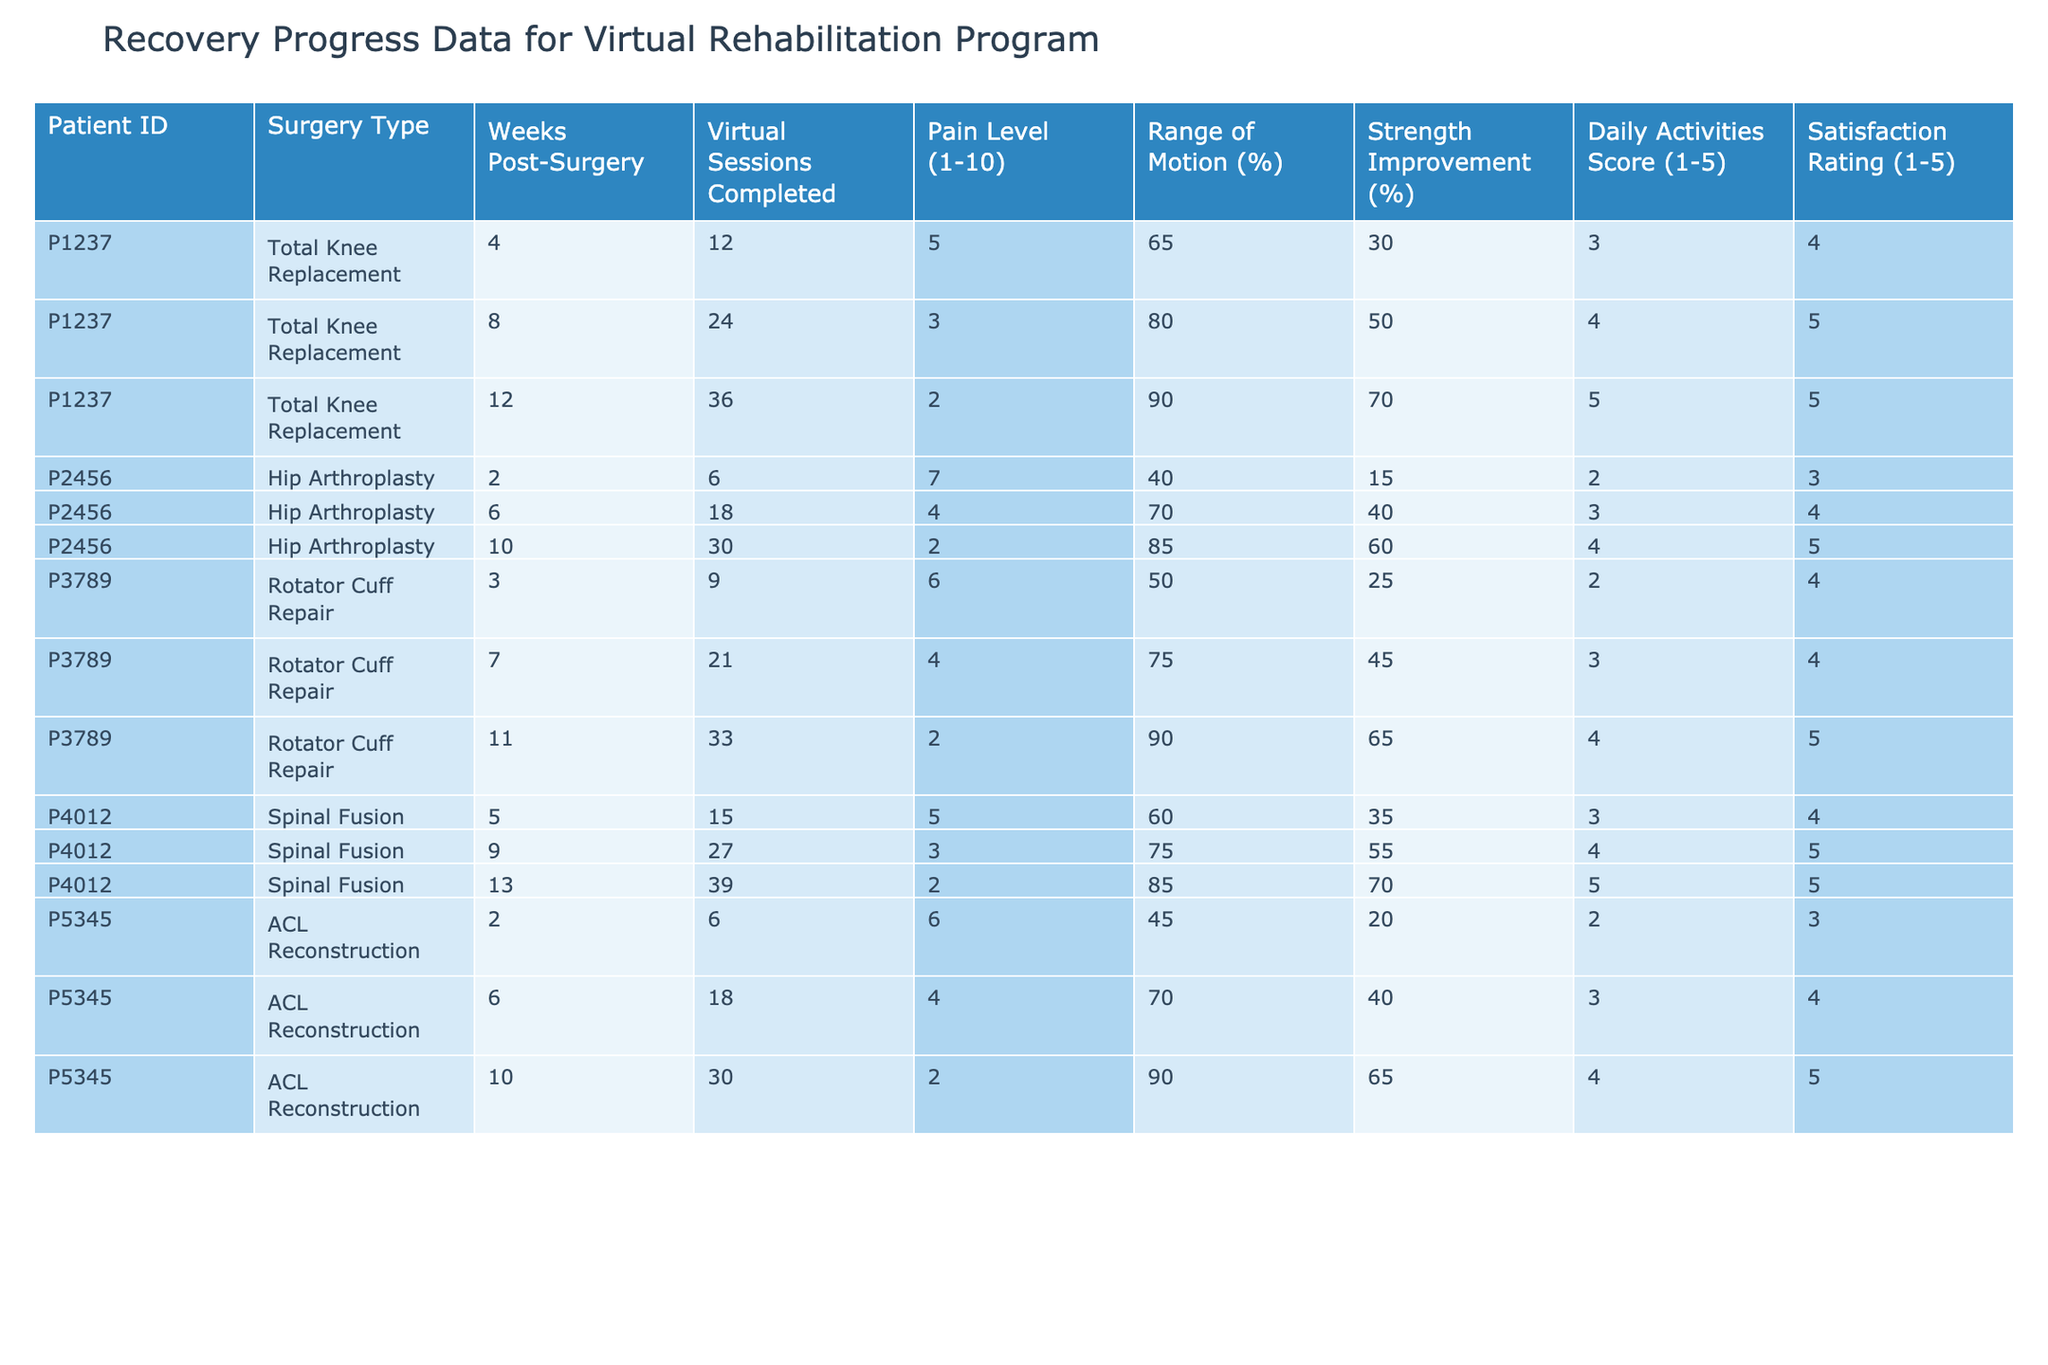What is the pain level for Patient P2456 at 10 weeks post-surgery? According to the table, for Patient P2456 at 10 weeks post-surgery, the pain level is recorded as 2.
Answer: 2 How many virtual sessions did Patient P1237 complete by week 12? For Patient P1237, the table shows that by week 12, they had completed 36 virtual sessions.
Answer: 36 What is the strength improvement percentage for Patient P4012 at 13 weeks post-surgery? The table indicates that for Patient P4012 at 13 weeks post-surgery, the strength improvement percentage is 70%.
Answer: 70% Which patient experienced a satisfaction rating of 5 at the 10-week mark? Checking the table, Patient P2456 received a satisfaction rating of 5 at the 10-week point.
Answer: Patient P2456 What is the average range of motion for all patients at 10 weeks post-surgery? To find the average range of motion at 10 weeks, we take the values from all patients at that time: (85 + 90 + 90) = 265, and divide by 3, which gives us an average of approximately 88.33%.
Answer: 88.33% Did any patient report a pain level lower than 3 at any time? Looking at the pain levels in the table, both Patient P2456 and Patient P3789 reported a pain level of 2 at different times, confirming that at least one patient reported a pain level lower than 3.
Answer: Yes Which surgery type shows the highest satisfaction rating, and what is that rating? The highest satisfaction rating of 5 is reported for the surgery types by Patients P1237, P2456, and P4012 at various weeks. Thus, the surgery types that show the highest rating are Total Knee Replacement, Hip Arthroplasty, and Spinal Fusion.
Answer: 5 What is the overall trend in the daily activities score for Patient P5345 over the weeks? For Patient P5345, the daily activities score increased from 2 at 2 weeks post-surgery to 4 at 10 weeks post-surgery, indicating an improvement in daily activity performance.
Answer: Improvement How many total virtual sessions did Patient P3789 complete from weeks 3 to 11? Adding the virtual sessions from the table for Patient P3789 shows 9, 21, and 33 sessions across weeks 3, 7, and 11 respectively, totaling to 63 sessions (9 + 21 + 33).
Answer: 63 Is there any patient whose pain level did not improve over time? Analyzing the pain levels for each patient over time, we see that Patient P1237's pain level increased from 5 to 2, thus showing improvement. In contrast, Patient P2456 showed a decline from 7 to 2, also indicating improvement. Therefore, no patient exhibited no improvement.
Answer: No 